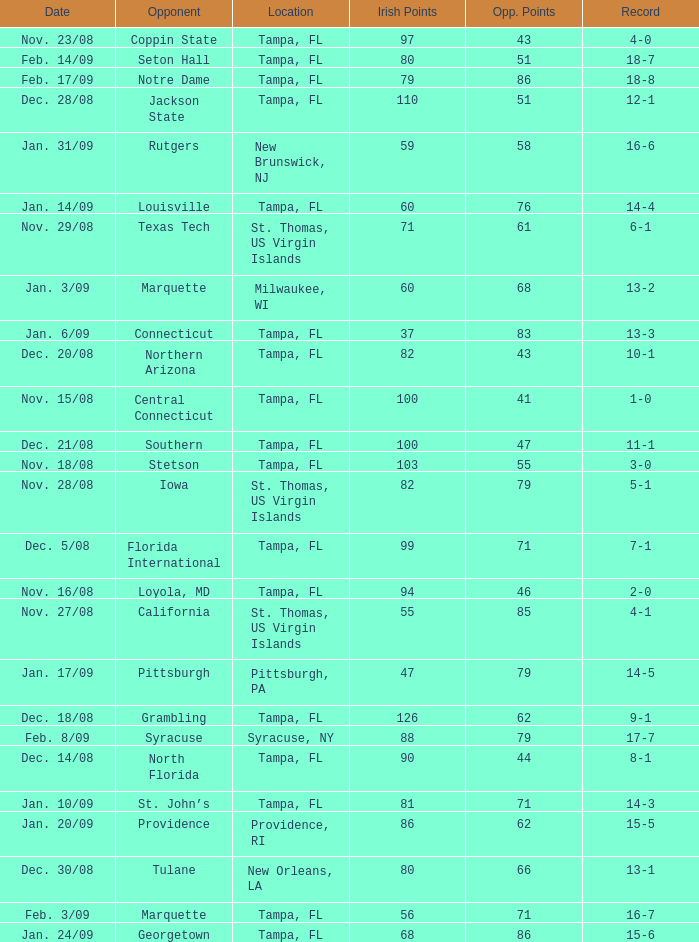What is the number of opponents where the location is syracuse, ny? 1.0. 